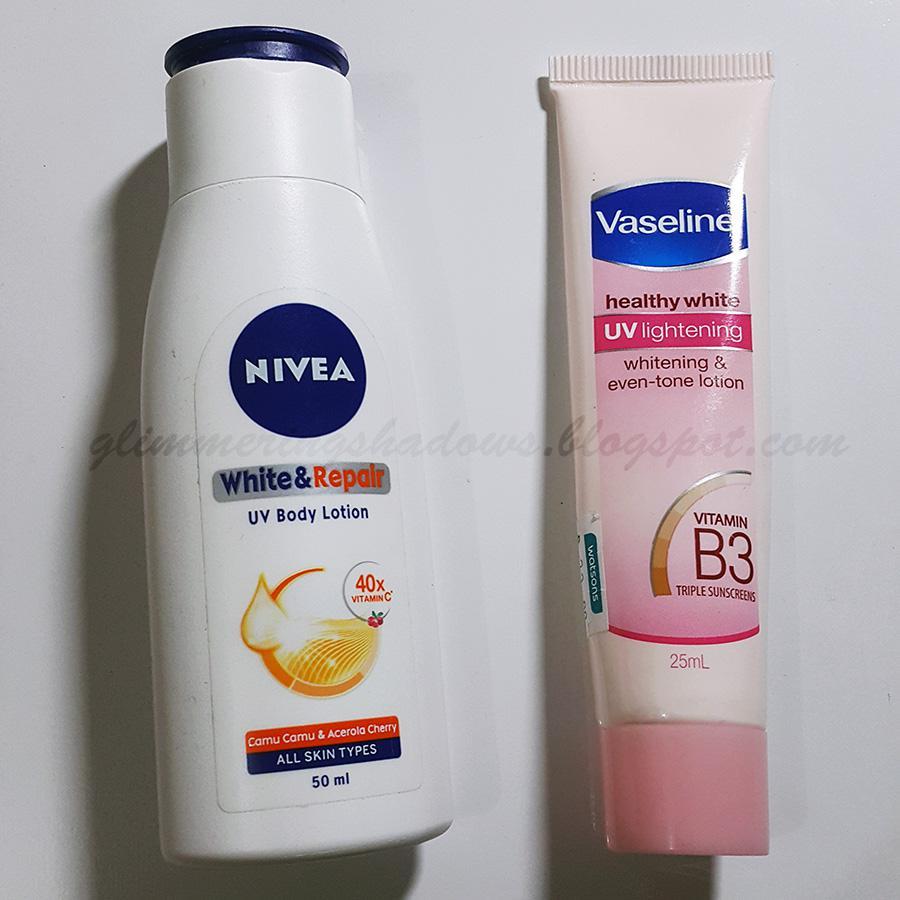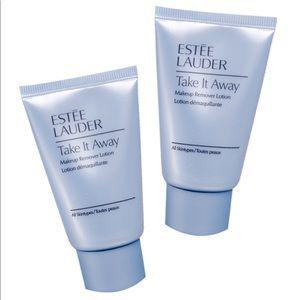The first image is the image on the left, the second image is the image on the right. Considering the images on both sides, is "We see three packages of lotion." valid? Answer yes or no. No. 